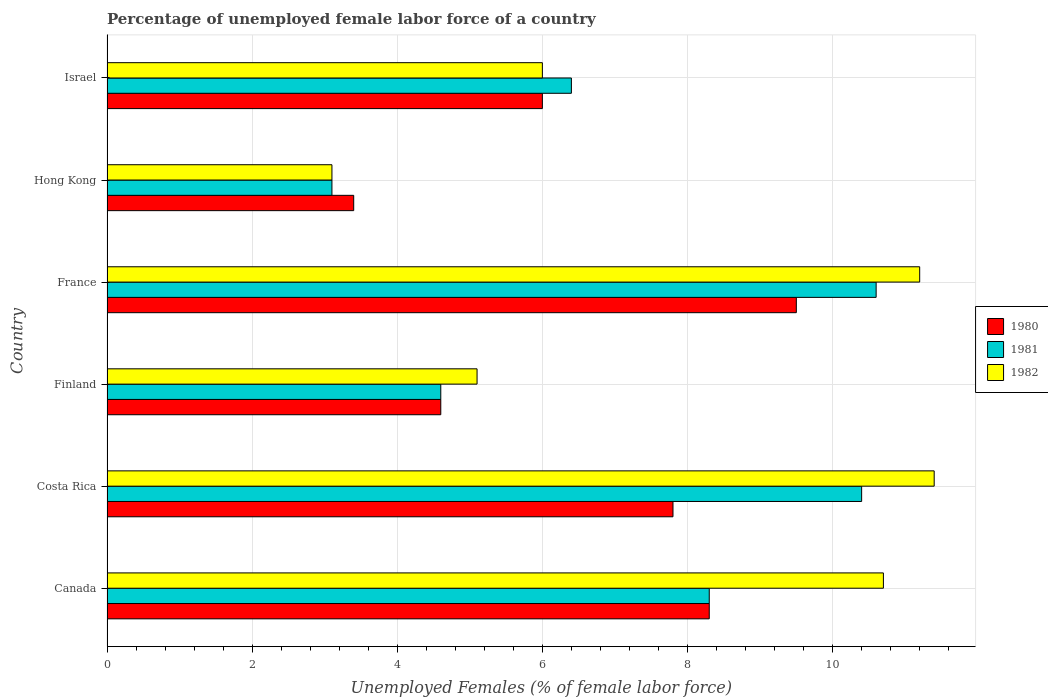How many different coloured bars are there?
Offer a very short reply. 3. Are the number of bars per tick equal to the number of legend labels?
Offer a very short reply. Yes. Are the number of bars on each tick of the Y-axis equal?
Provide a short and direct response. Yes. How many bars are there on the 4th tick from the top?
Give a very brief answer. 3. How many bars are there on the 2nd tick from the bottom?
Offer a very short reply. 3. What is the label of the 5th group of bars from the top?
Offer a terse response. Costa Rica. What is the percentage of unemployed female labor force in 1980 in France?
Your answer should be compact. 9.5. Across all countries, what is the maximum percentage of unemployed female labor force in 1982?
Provide a succinct answer. 11.4. Across all countries, what is the minimum percentage of unemployed female labor force in 1982?
Your answer should be compact. 3.1. In which country was the percentage of unemployed female labor force in 1982 minimum?
Give a very brief answer. Hong Kong. What is the total percentage of unemployed female labor force in 1982 in the graph?
Keep it short and to the point. 47.5. What is the difference between the percentage of unemployed female labor force in 1981 in Hong Kong and that in Israel?
Your answer should be compact. -3.3. What is the difference between the percentage of unemployed female labor force in 1980 in Hong Kong and the percentage of unemployed female labor force in 1981 in Canada?
Your answer should be compact. -4.9. What is the average percentage of unemployed female labor force in 1982 per country?
Your response must be concise. 7.92. What is the difference between the percentage of unemployed female labor force in 1982 and percentage of unemployed female labor force in 1980 in Canada?
Make the answer very short. 2.4. In how many countries, is the percentage of unemployed female labor force in 1980 greater than 4 %?
Ensure brevity in your answer.  5. What is the ratio of the percentage of unemployed female labor force in 1981 in Costa Rica to that in Israel?
Give a very brief answer. 1.62. What is the difference between the highest and the second highest percentage of unemployed female labor force in 1980?
Provide a short and direct response. 1.2. What is the difference between the highest and the lowest percentage of unemployed female labor force in 1980?
Ensure brevity in your answer.  6.1. In how many countries, is the percentage of unemployed female labor force in 1980 greater than the average percentage of unemployed female labor force in 1980 taken over all countries?
Keep it short and to the point. 3. Is the sum of the percentage of unemployed female labor force in 1981 in France and Israel greater than the maximum percentage of unemployed female labor force in 1980 across all countries?
Make the answer very short. Yes. Are all the bars in the graph horizontal?
Make the answer very short. Yes. How many countries are there in the graph?
Offer a very short reply. 6. Does the graph contain any zero values?
Make the answer very short. No. What is the title of the graph?
Give a very brief answer. Percentage of unemployed female labor force of a country. What is the label or title of the X-axis?
Make the answer very short. Unemployed Females (% of female labor force). What is the Unemployed Females (% of female labor force) in 1980 in Canada?
Keep it short and to the point. 8.3. What is the Unemployed Females (% of female labor force) in 1981 in Canada?
Your answer should be compact. 8.3. What is the Unemployed Females (% of female labor force) in 1982 in Canada?
Your answer should be very brief. 10.7. What is the Unemployed Females (% of female labor force) of 1980 in Costa Rica?
Provide a short and direct response. 7.8. What is the Unemployed Females (% of female labor force) in 1981 in Costa Rica?
Provide a short and direct response. 10.4. What is the Unemployed Females (% of female labor force) in 1982 in Costa Rica?
Your answer should be very brief. 11.4. What is the Unemployed Females (% of female labor force) in 1980 in Finland?
Provide a succinct answer. 4.6. What is the Unemployed Females (% of female labor force) in 1981 in Finland?
Your answer should be very brief. 4.6. What is the Unemployed Females (% of female labor force) of 1982 in Finland?
Your answer should be compact. 5.1. What is the Unemployed Females (% of female labor force) in 1980 in France?
Provide a short and direct response. 9.5. What is the Unemployed Females (% of female labor force) of 1981 in France?
Your response must be concise. 10.6. What is the Unemployed Females (% of female labor force) of 1982 in France?
Provide a succinct answer. 11.2. What is the Unemployed Females (% of female labor force) of 1980 in Hong Kong?
Provide a short and direct response. 3.4. What is the Unemployed Females (% of female labor force) of 1981 in Hong Kong?
Ensure brevity in your answer.  3.1. What is the Unemployed Females (% of female labor force) in 1982 in Hong Kong?
Your response must be concise. 3.1. What is the Unemployed Females (% of female labor force) of 1981 in Israel?
Your answer should be very brief. 6.4. Across all countries, what is the maximum Unemployed Females (% of female labor force) in 1981?
Provide a short and direct response. 10.6. Across all countries, what is the maximum Unemployed Females (% of female labor force) of 1982?
Your answer should be very brief. 11.4. Across all countries, what is the minimum Unemployed Females (% of female labor force) in 1980?
Your answer should be compact. 3.4. Across all countries, what is the minimum Unemployed Females (% of female labor force) in 1981?
Keep it short and to the point. 3.1. Across all countries, what is the minimum Unemployed Females (% of female labor force) in 1982?
Ensure brevity in your answer.  3.1. What is the total Unemployed Females (% of female labor force) in 1980 in the graph?
Your response must be concise. 39.6. What is the total Unemployed Females (% of female labor force) of 1981 in the graph?
Your answer should be compact. 43.4. What is the total Unemployed Females (% of female labor force) in 1982 in the graph?
Provide a succinct answer. 47.5. What is the difference between the Unemployed Females (% of female labor force) of 1981 in Canada and that in Costa Rica?
Ensure brevity in your answer.  -2.1. What is the difference between the Unemployed Females (% of female labor force) of 1982 in Canada and that in Costa Rica?
Provide a short and direct response. -0.7. What is the difference between the Unemployed Females (% of female labor force) of 1980 in Canada and that in Finland?
Offer a very short reply. 3.7. What is the difference between the Unemployed Females (% of female labor force) in 1982 in Canada and that in Finland?
Provide a succinct answer. 5.6. What is the difference between the Unemployed Females (% of female labor force) of 1980 in Canada and that in France?
Offer a terse response. -1.2. What is the difference between the Unemployed Females (% of female labor force) in 1981 in Canada and that in France?
Your response must be concise. -2.3. What is the difference between the Unemployed Females (% of female labor force) in 1982 in Canada and that in France?
Keep it short and to the point. -0.5. What is the difference between the Unemployed Females (% of female labor force) of 1982 in Canada and that in Hong Kong?
Offer a terse response. 7.6. What is the difference between the Unemployed Females (% of female labor force) in 1981 in Canada and that in Israel?
Your response must be concise. 1.9. What is the difference between the Unemployed Females (% of female labor force) of 1982 in Canada and that in Israel?
Keep it short and to the point. 4.7. What is the difference between the Unemployed Females (% of female labor force) of 1980 in Costa Rica and that in Finland?
Keep it short and to the point. 3.2. What is the difference between the Unemployed Females (% of female labor force) in 1981 in Costa Rica and that in Finland?
Your response must be concise. 5.8. What is the difference between the Unemployed Females (% of female labor force) of 1980 in Costa Rica and that in France?
Your answer should be compact. -1.7. What is the difference between the Unemployed Females (% of female labor force) of 1981 in Costa Rica and that in France?
Your response must be concise. -0.2. What is the difference between the Unemployed Females (% of female labor force) of 1980 in Costa Rica and that in Hong Kong?
Offer a very short reply. 4.4. What is the difference between the Unemployed Females (% of female labor force) of 1980 in Costa Rica and that in Israel?
Offer a terse response. 1.8. What is the difference between the Unemployed Females (% of female labor force) in 1981 in Finland and that in France?
Keep it short and to the point. -6. What is the difference between the Unemployed Females (% of female labor force) of 1980 in Finland and that in Hong Kong?
Make the answer very short. 1.2. What is the difference between the Unemployed Females (% of female labor force) in 1982 in Finland and that in Hong Kong?
Offer a very short reply. 2. What is the difference between the Unemployed Females (% of female labor force) of 1981 in France and that in Hong Kong?
Provide a short and direct response. 7.5. What is the difference between the Unemployed Females (% of female labor force) of 1982 in France and that in Hong Kong?
Give a very brief answer. 8.1. What is the difference between the Unemployed Females (% of female labor force) of 1981 in France and that in Israel?
Give a very brief answer. 4.2. What is the difference between the Unemployed Females (% of female labor force) of 1982 in France and that in Israel?
Provide a succinct answer. 5.2. What is the difference between the Unemployed Females (% of female labor force) in 1981 in Hong Kong and that in Israel?
Keep it short and to the point. -3.3. What is the difference between the Unemployed Females (% of female labor force) in 1982 in Hong Kong and that in Israel?
Make the answer very short. -2.9. What is the difference between the Unemployed Females (% of female labor force) in 1980 in Canada and the Unemployed Females (% of female labor force) in 1981 in Finland?
Offer a terse response. 3.7. What is the difference between the Unemployed Females (% of female labor force) of 1980 in Canada and the Unemployed Females (% of female labor force) of 1982 in Finland?
Give a very brief answer. 3.2. What is the difference between the Unemployed Females (% of female labor force) in 1981 in Canada and the Unemployed Females (% of female labor force) in 1982 in Finland?
Give a very brief answer. 3.2. What is the difference between the Unemployed Females (% of female labor force) of 1980 in Canada and the Unemployed Females (% of female labor force) of 1981 in France?
Provide a succinct answer. -2.3. What is the difference between the Unemployed Females (% of female labor force) in 1980 in Canada and the Unemployed Females (% of female labor force) in 1982 in Hong Kong?
Ensure brevity in your answer.  5.2. What is the difference between the Unemployed Females (% of female labor force) in 1981 in Canada and the Unemployed Females (% of female labor force) in 1982 in Israel?
Make the answer very short. 2.3. What is the difference between the Unemployed Females (% of female labor force) in 1980 in Costa Rica and the Unemployed Females (% of female labor force) in 1981 in Finland?
Provide a succinct answer. 3.2. What is the difference between the Unemployed Females (% of female labor force) of 1980 in Costa Rica and the Unemployed Females (% of female labor force) of 1982 in Finland?
Your response must be concise. 2.7. What is the difference between the Unemployed Females (% of female labor force) in 1981 in Costa Rica and the Unemployed Females (% of female labor force) in 1982 in Finland?
Your answer should be compact. 5.3. What is the difference between the Unemployed Females (% of female labor force) of 1980 in Costa Rica and the Unemployed Females (% of female labor force) of 1982 in Hong Kong?
Your answer should be very brief. 4.7. What is the difference between the Unemployed Females (% of female labor force) in 1981 in Costa Rica and the Unemployed Females (% of female labor force) in 1982 in Hong Kong?
Make the answer very short. 7.3. What is the difference between the Unemployed Females (% of female labor force) of 1980 in Costa Rica and the Unemployed Females (% of female labor force) of 1981 in Israel?
Your answer should be very brief. 1.4. What is the difference between the Unemployed Females (% of female labor force) of 1980 in Costa Rica and the Unemployed Females (% of female labor force) of 1982 in Israel?
Give a very brief answer. 1.8. What is the difference between the Unemployed Females (% of female labor force) of 1980 in Finland and the Unemployed Females (% of female labor force) of 1981 in France?
Your answer should be compact. -6. What is the difference between the Unemployed Females (% of female labor force) of 1980 in Finland and the Unemployed Females (% of female labor force) of 1982 in France?
Your answer should be very brief. -6.6. What is the difference between the Unemployed Females (% of female labor force) of 1980 in Finland and the Unemployed Females (% of female labor force) of 1981 in Israel?
Offer a terse response. -1.8. What is the difference between the Unemployed Females (% of female labor force) of 1980 in France and the Unemployed Females (% of female labor force) of 1981 in Hong Kong?
Offer a terse response. 6.4. What is the difference between the Unemployed Females (% of female labor force) of 1980 in France and the Unemployed Females (% of female labor force) of 1981 in Israel?
Offer a very short reply. 3.1. What is the difference between the Unemployed Females (% of female labor force) of 1980 in France and the Unemployed Females (% of female labor force) of 1982 in Israel?
Your answer should be very brief. 3.5. What is the difference between the Unemployed Females (% of female labor force) in 1981 in France and the Unemployed Females (% of female labor force) in 1982 in Israel?
Give a very brief answer. 4.6. What is the difference between the Unemployed Females (% of female labor force) in 1980 in Hong Kong and the Unemployed Females (% of female labor force) in 1981 in Israel?
Offer a terse response. -3. What is the average Unemployed Females (% of female labor force) in 1980 per country?
Keep it short and to the point. 6.6. What is the average Unemployed Females (% of female labor force) in 1981 per country?
Give a very brief answer. 7.23. What is the average Unemployed Females (% of female labor force) of 1982 per country?
Make the answer very short. 7.92. What is the difference between the Unemployed Females (% of female labor force) of 1980 and Unemployed Females (% of female labor force) of 1981 in Canada?
Give a very brief answer. 0. What is the difference between the Unemployed Females (% of female labor force) in 1981 and Unemployed Females (% of female labor force) in 1982 in Canada?
Your answer should be compact. -2.4. What is the difference between the Unemployed Females (% of female labor force) of 1980 and Unemployed Females (% of female labor force) of 1982 in Finland?
Offer a very short reply. -0.5. What is the difference between the Unemployed Females (% of female labor force) of 1981 and Unemployed Females (% of female labor force) of 1982 in Finland?
Give a very brief answer. -0.5. What is the difference between the Unemployed Females (% of female labor force) of 1980 and Unemployed Females (% of female labor force) of 1982 in Hong Kong?
Make the answer very short. 0.3. What is the difference between the Unemployed Females (% of female labor force) of 1981 and Unemployed Females (% of female labor force) of 1982 in Hong Kong?
Your response must be concise. 0. What is the difference between the Unemployed Females (% of female labor force) in 1981 and Unemployed Females (% of female labor force) in 1982 in Israel?
Your answer should be very brief. 0.4. What is the ratio of the Unemployed Females (% of female labor force) of 1980 in Canada to that in Costa Rica?
Give a very brief answer. 1.06. What is the ratio of the Unemployed Females (% of female labor force) in 1981 in Canada to that in Costa Rica?
Your answer should be compact. 0.8. What is the ratio of the Unemployed Females (% of female labor force) of 1982 in Canada to that in Costa Rica?
Your answer should be very brief. 0.94. What is the ratio of the Unemployed Females (% of female labor force) in 1980 in Canada to that in Finland?
Offer a very short reply. 1.8. What is the ratio of the Unemployed Females (% of female labor force) in 1981 in Canada to that in Finland?
Ensure brevity in your answer.  1.8. What is the ratio of the Unemployed Females (% of female labor force) in 1982 in Canada to that in Finland?
Ensure brevity in your answer.  2.1. What is the ratio of the Unemployed Females (% of female labor force) in 1980 in Canada to that in France?
Offer a terse response. 0.87. What is the ratio of the Unemployed Females (% of female labor force) in 1981 in Canada to that in France?
Ensure brevity in your answer.  0.78. What is the ratio of the Unemployed Females (% of female labor force) in 1982 in Canada to that in France?
Offer a terse response. 0.96. What is the ratio of the Unemployed Females (% of female labor force) in 1980 in Canada to that in Hong Kong?
Offer a very short reply. 2.44. What is the ratio of the Unemployed Females (% of female labor force) of 1981 in Canada to that in Hong Kong?
Offer a very short reply. 2.68. What is the ratio of the Unemployed Females (% of female labor force) of 1982 in Canada to that in Hong Kong?
Make the answer very short. 3.45. What is the ratio of the Unemployed Females (% of female labor force) in 1980 in Canada to that in Israel?
Keep it short and to the point. 1.38. What is the ratio of the Unemployed Females (% of female labor force) in 1981 in Canada to that in Israel?
Your answer should be compact. 1.3. What is the ratio of the Unemployed Females (% of female labor force) of 1982 in Canada to that in Israel?
Give a very brief answer. 1.78. What is the ratio of the Unemployed Females (% of female labor force) of 1980 in Costa Rica to that in Finland?
Provide a succinct answer. 1.7. What is the ratio of the Unemployed Females (% of female labor force) of 1981 in Costa Rica to that in Finland?
Provide a short and direct response. 2.26. What is the ratio of the Unemployed Females (% of female labor force) of 1982 in Costa Rica to that in Finland?
Offer a terse response. 2.24. What is the ratio of the Unemployed Females (% of female labor force) in 1980 in Costa Rica to that in France?
Keep it short and to the point. 0.82. What is the ratio of the Unemployed Females (% of female labor force) in 1981 in Costa Rica to that in France?
Provide a short and direct response. 0.98. What is the ratio of the Unemployed Females (% of female labor force) in 1982 in Costa Rica to that in France?
Offer a very short reply. 1.02. What is the ratio of the Unemployed Females (% of female labor force) of 1980 in Costa Rica to that in Hong Kong?
Give a very brief answer. 2.29. What is the ratio of the Unemployed Females (% of female labor force) in 1981 in Costa Rica to that in Hong Kong?
Offer a terse response. 3.35. What is the ratio of the Unemployed Females (% of female labor force) of 1982 in Costa Rica to that in Hong Kong?
Give a very brief answer. 3.68. What is the ratio of the Unemployed Females (% of female labor force) in 1980 in Costa Rica to that in Israel?
Provide a short and direct response. 1.3. What is the ratio of the Unemployed Females (% of female labor force) of 1981 in Costa Rica to that in Israel?
Give a very brief answer. 1.62. What is the ratio of the Unemployed Females (% of female labor force) of 1980 in Finland to that in France?
Your answer should be compact. 0.48. What is the ratio of the Unemployed Females (% of female labor force) of 1981 in Finland to that in France?
Provide a succinct answer. 0.43. What is the ratio of the Unemployed Females (% of female labor force) of 1982 in Finland to that in France?
Ensure brevity in your answer.  0.46. What is the ratio of the Unemployed Females (% of female labor force) of 1980 in Finland to that in Hong Kong?
Your answer should be very brief. 1.35. What is the ratio of the Unemployed Females (% of female labor force) in 1981 in Finland to that in Hong Kong?
Make the answer very short. 1.48. What is the ratio of the Unemployed Females (% of female labor force) in 1982 in Finland to that in Hong Kong?
Provide a succinct answer. 1.65. What is the ratio of the Unemployed Females (% of female labor force) of 1980 in Finland to that in Israel?
Your response must be concise. 0.77. What is the ratio of the Unemployed Females (% of female labor force) of 1981 in Finland to that in Israel?
Offer a very short reply. 0.72. What is the ratio of the Unemployed Females (% of female labor force) in 1982 in Finland to that in Israel?
Ensure brevity in your answer.  0.85. What is the ratio of the Unemployed Females (% of female labor force) in 1980 in France to that in Hong Kong?
Provide a short and direct response. 2.79. What is the ratio of the Unemployed Females (% of female labor force) of 1981 in France to that in Hong Kong?
Keep it short and to the point. 3.42. What is the ratio of the Unemployed Females (% of female labor force) of 1982 in France to that in Hong Kong?
Give a very brief answer. 3.61. What is the ratio of the Unemployed Females (% of female labor force) of 1980 in France to that in Israel?
Offer a very short reply. 1.58. What is the ratio of the Unemployed Females (% of female labor force) of 1981 in France to that in Israel?
Your answer should be compact. 1.66. What is the ratio of the Unemployed Females (% of female labor force) in 1982 in France to that in Israel?
Give a very brief answer. 1.87. What is the ratio of the Unemployed Females (% of female labor force) in 1980 in Hong Kong to that in Israel?
Your answer should be compact. 0.57. What is the ratio of the Unemployed Females (% of female labor force) in 1981 in Hong Kong to that in Israel?
Offer a terse response. 0.48. What is the ratio of the Unemployed Females (% of female labor force) in 1982 in Hong Kong to that in Israel?
Your response must be concise. 0.52. What is the difference between the highest and the second highest Unemployed Females (% of female labor force) in 1981?
Your answer should be very brief. 0.2. What is the difference between the highest and the lowest Unemployed Females (% of female labor force) of 1981?
Offer a terse response. 7.5. What is the difference between the highest and the lowest Unemployed Females (% of female labor force) of 1982?
Offer a terse response. 8.3. 